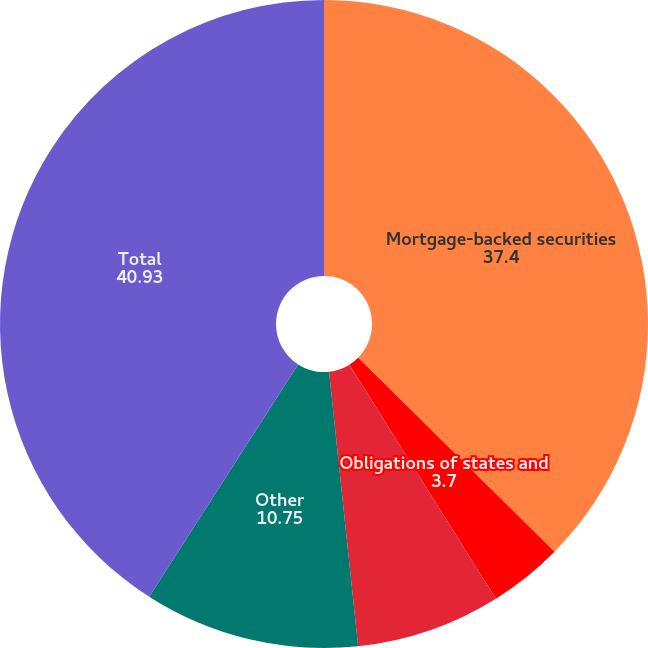Convert chart. <chart><loc_0><loc_0><loc_500><loc_500><pie_chart><fcel>Mortgage-backed securities<fcel>Obligations of states and<fcel>US corporate bonds<fcel>Other<fcel>Total<nl><fcel>37.4%<fcel>3.7%<fcel>7.22%<fcel>10.75%<fcel>40.93%<nl></chart> 